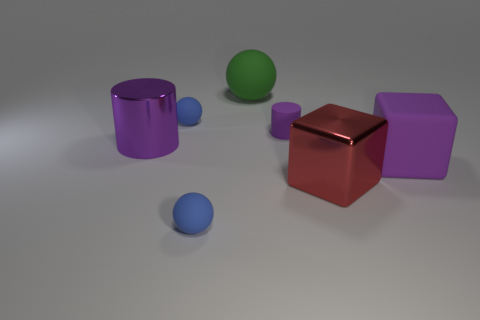Subtract all green matte balls. How many balls are left? 2 Add 1 small rubber cylinders. How many objects exist? 8 Subtract 1 cylinders. How many cylinders are left? 1 Subtract all green balls. How many balls are left? 2 Add 3 green balls. How many green balls are left? 4 Add 5 large purple blocks. How many large purple blocks exist? 6 Subtract 0 brown blocks. How many objects are left? 7 Subtract all cubes. How many objects are left? 5 Subtract all gray blocks. Subtract all cyan cylinders. How many blocks are left? 2 Subtract all gray balls. How many green cubes are left? 0 